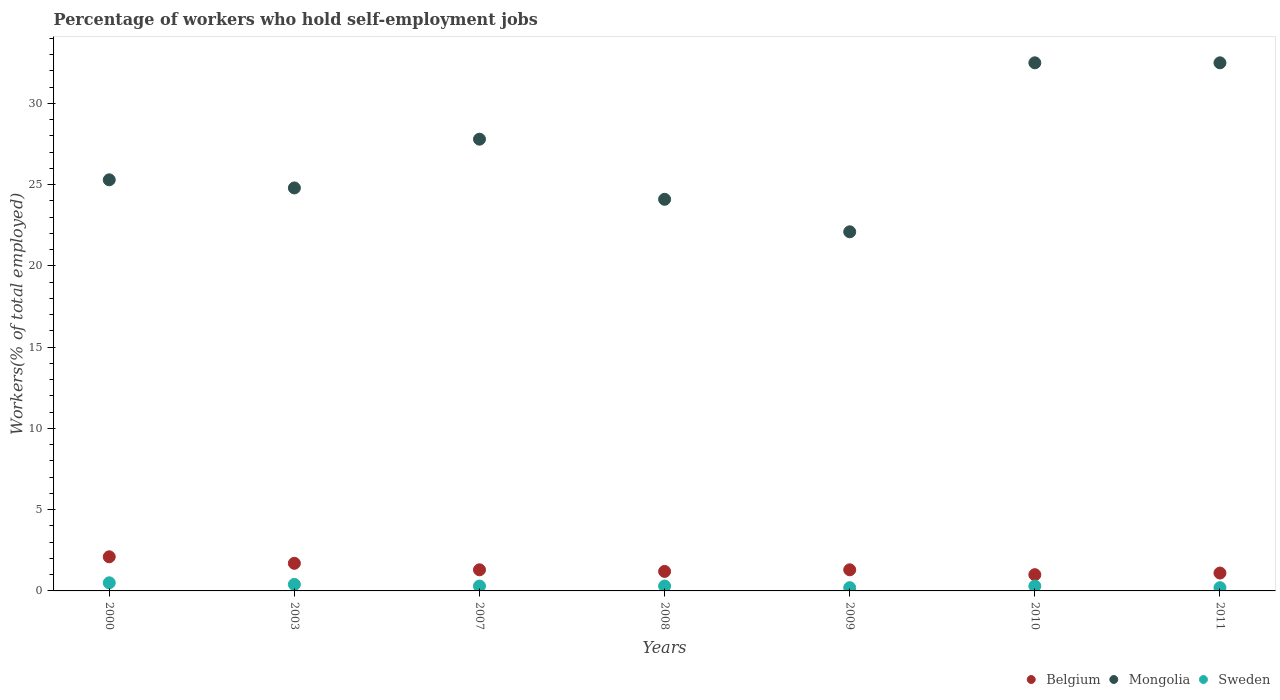How many different coloured dotlines are there?
Provide a succinct answer. 3. Is the number of dotlines equal to the number of legend labels?
Your answer should be compact. Yes. What is the percentage of self-employed workers in Belgium in 2003?
Give a very brief answer. 1.7. Across all years, what is the maximum percentage of self-employed workers in Sweden?
Ensure brevity in your answer.  0.5. Across all years, what is the minimum percentage of self-employed workers in Mongolia?
Your answer should be compact. 22.1. In which year was the percentage of self-employed workers in Belgium minimum?
Offer a terse response. 2010. What is the total percentage of self-employed workers in Sweden in the graph?
Provide a short and direct response. 2.2. What is the difference between the percentage of self-employed workers in Belgium in 2003 and that in 2007?
Your answer should be compact. 0.4. What is the difference between the percentage of self-employed workers in Sweden in 2008 and the percentage of self-employed workers in Belgium in 2010?
Your response must be concise. -0.7. What is the average percentage of self-employed workers in Sweden per year?
Offer a very short reply. 0.31. In the year 2009, what is the difference between the percentage of self-employed workers in Mongolia and percentage of self-employed workers in Sweden?
Provide a succinct answer. 21.9. In how many years, is the percentage of self-employed workers in Belgium greater than 18 %?
Keep it short and to the point. 0. What is the ratio of the percentage of self-employed workers in Belgium in 2009 to that in 2010?
Give a very brief answer. 1.3. What is the difference between the highest and the second highest percentage of self-employed workers in Mongolia?
Your answer should be compact. 0. What is the difference between the highest and the lowest percentage of self-employed workers in Mongolia?
Ensure brevity in your answer.  10.4. In how many years, is the percentage of self-employed workers in Sweden greater than the average percentage of self-employed workers in Sweden taken over all years?
Offer a terse response. 2. Is the percentage of self-employed workers in Mongolia strictly greater than the percentage of self-employed workers in Sweden over the years?
Provide a succinct answer. Yes. How many dotlines are there?
Offer a very short reply. 3. What is the difference between two consecutive major ticks on the Y-axis?
Provide a succinct answer. 5. Are the values on the major ticks of Y-axis written in scientific E-notation?
Give a very brief answer. No. Does the graph contain grids?
Make the answer very short. No. What is the title of the graph?
Offer a terse response. Percentage of workers who hold self-employment jobs. Does "Colombia" appear as one of the legend labels in the graph?
Keep it short and to the point. No. What is the label or title of the X-axis?
Your response must be concise. Years. What is the label or title of the Y-axis?
Keep it short and to the point. Workers(% of total employed). What is the Workers(% of total employed) of Belgium in 2000?
Offer a very short reply. 2.1. What is the Workers(% of total employed) in Mongolia in 2000?
Make the answer very short. 25.3. What is the Workers(% of total employed) in Belgium in 2003?
Provide a short and direct response. 1.7. What is the Workers(% of total employed) in Mongolia in 2003?
Provide a succinct answer. 24.8. What is the Workers(% of total employed) of Sweden in 2003?
Ensure brevity in your answer.  0.4. What is the Workers(% of total employed) in Belgium in 2007?
Give a very brief answer. 1.3. What is the Workers(% of total employed) of Mongolia in 2007?
Provide a short and direct response. 27.8. What is the Workers(% of total employed) in Sweden in 2007?
Your response must be concise. 0.3. What is the Workers(% of total employed) in Belgium in 2008?
Provide a short and direct response. 1.2. What is the Workers(% of total employed) of Mongolia in 2008?
Provide a short and direct response. 24.1. What is the Workers(% of total employed) in Sweden in 2008?
Keep it short and to the point. 0.3. What is the Workers(% of total employed) of Belgium in 2009?
Provide a short and direct response. 1.3. What is the Workers(% of total employed) of Mongolia in 2009?
Offer a very short reply. 22.1. What is the Workers(% of total employed) in Sweden in 2009?
Provide a short and direct response. 0.2. What is the Workers(% of total employed) of Belgium in 2010?
Your answer should be very brief. 1. What is the Workers(% of total employed) of Mongolia in 2010?
Your response must be concise. 32.5. What is the Workers(% of total employed) of Sweden in 2010?
Your answer should be very brief. 0.3. What is the Workers(% of total employed) of Belgium in 2011?
Make the answer very short. 1.1. What is the Workers(% of total employed) in Mongolia in 2011?
Your response must be concise. 32.5. What is the Workers(% of total employed) of Sweden in 2011?
Your response must be concise. 0.2. Across all years, what is the maximum Workers(% of total employed) of Belgium?
Your answer should be compact. 2.1. Across all years, what is the maximum Workers(% of total employed) of Mongolia?
Your answer should be very brief. 32.5. Across all years, what is the minimum Workers(% of total employed) of Belgium?
Ensure brevity in your answer.  1. Across all years, what is the minimum Workers(% of total employed) of Mongolia?
Your answer should be very brief. 22.1. Across all years, what is the minimum Workers(% of total employed) in Sweden?
Provide a short and direct response. 0.2. What is the total Workers(% of total employed) of Mongolia in the graph?
Provide a succinct answer. 189.1. What is the total Workers(% of total employed) of Sweden in the graph?
Provide a succinct answer. 2.2. What is the difference between the Workers(% of total employed) in Belgium in 2000 and that in 2003?
Your response must be concise. 0.4. What is the difference between the Workers(% of total employed) in Sweden in 2000 and that in 2003?
Your answer should be compact. 0.1. What is the difference between the Workers(% of total employed) of Mongolia in 2000 and that in 2007?
Your response must be concise. -2.5. What is the difference between the Workers(% of total employed) in Sweden in 2000 and that in 2007?
Keep it short and to the point. 0.2. What is the difference between the Workers(% of total employed) of Mongolia in 2000 and that in 2008?
Your answer should be compact. 1.2. What is the difference between the Workers(% of total employed) of Sweden in 2000 and that in 2008?
Make the answer very short. 0.2. What is the difference between the Workers(% of total employed) in Mongolia in 2000 and that in 2009?
Keep it short and to the point. 3.2. What is the difference between the Workers(% of total employed) of Sweden in 2000 and that in 2009?
Offer a terse response. 0.3. What is the difference between the Workers(% of total employed) of Mongolia in 2000 and that in 2010?
Provide a short and direct response. -7.2. What is the difference between the Workers(% of total employed) of Sweden in 2000 and that in 2011?
Make the answer very short. 0.3. What is the difference between the Workers(% of total employed) of Mongolia in 2003 and that in 2007?
Keep it short and to the point. -3. What is the difference between the Workers(% of total employed) of Mongolia in 2003 and that in 2008?
Ensure brevity in your answer.  0.7. What is the difference between the Workers(% of total employed) in Sweden in 2003 and that in 2008?
Give a very brief answer. 0.1. What is the difference between the Workers(% of total employed) of Belgium in 2003 and that in 2009?
Give a very brief answer. 0.4. What is the difference between the Workers(% of total employed) of Mongolia in 2003 and that in 2009?
Your answer should be compact. 2.7. What is the difference between the Workers(% of total employed) in Mongolia in 2003 and that in 2010?
Provide a succinct answer. -7.7. What is the difference between the Workers(% of total employed) in Belgium in 2003 and that in 2011?
Your answer should be compact. 0.6. What is the difference between the Workers(% of total employed) in Mongolia in 2003 and that in 2011?
Give a very brief answer. -7.7. What is the difference between the Workers(% of total employed) of Sweden in 2003 and that in 2011?
Offer a terse response. 0.2. What is the difference between the Workers(% of total employed) of Mongolia in 2007 and that in 2008?
Provide a succinct answer. 3.7. What is the difference between the Workers(% of total employed) of Belgium in 2007 and that in 2009?
Offer a terse response. 0. What is the difference between the Workers(% of total employed) of Mongolia in 2007 and that in 2009?
Offer a terse response. 5.7. What is the difference between the Workers(% of total employed) in Sweden in 2007 and that in 2010?
Provide a short and direct response. 0. What is the difference between the Workers(% of total employed) of Mongolia in 2007 and that in 2011?
Offer a terse response. -4.7. What is the difference between the Workers(% of total employed) of Belgium in 2008 and that in 2009?
Offer a terse response. -0.1. What is the difference between the Workers(% of total employed) in Sweden in 2008 and that in 2009?
Give a very brief answer. 0.1. What is the difference between the Workers(% of total employed) of Belgium in 2008 and that in 2010?
Provide a succinct answer. 0.2. What is the difference between the Workers(% of total employed) of Sweden in 2008 and that in 2010?
Your answer should be compact. 0. What is the difference between the Workers(% of total employed) in Belgium in 2008 and that in 2011?
Keep it short and to the point. 0.1. What is the difference between the Workers(% of total employed) of Sweden in 2008 and that in 2011?
Provide a short and direct response. 0.1. What is the difference between the Workers(% of total employed) in Sweden in 2009 and that in 2010?
Provide a succinct answer. -0.1. What is the difference between the Workers(% of total employed) of Belgium in 2009 and that in 2011?
Provide a short and direct response. 0.2. What is the difference between the Workers(% of total employed) in Mongolia in 2009 and that in 2011?
Give a very brief answer. -10.4. What is the difference between the Workers(% of total employed) of Sweden in 2009 and that in 2011?
Your answer should be very brief. 0. What is the difference between the Workers(% of total employed) in Belgium in 2000 and the Workers(% of total employed) in Mongolia in 2003?
Offer a terse response. -22.7. What is the difference between the Workers(% of total employed) in Belgium in 2000 and the Workers(% of total employed) in Sweden in 2003?
Ensure brevity in your answer.  1.7. What is the difference between the Workers(% of total employed) in Mongolia in 2000 and the Workers(% of total employed) in Sweden in 2003?
Provide a succinct answer. 24.9. What is the difference between the Workers(% of total employed) of Belgium in 2000 and the Workers(% of total employed) of Mongolia in 2007?
Offer a terse response. -25.7. What is the difference between the Workers(% of total employed) in Belgium in 2000 and the Workers(% of total employed) in Sweden in 2007?
Make the answer very short. 1.8. What is the difference between the Workers(% of total employed) in Belgium in 2000 and the Workers(% of total employed) in Mongolia in 2008?
Provide a succinct answer. -22. What is the difference between the Workers(% of total employed) of Mongolia in 2000 and the Workers(% of total employed) of Sweden in 2008?
Ensure brevity in your answer.  25. What is the difference between the Workers(% of total employed) of Belgium in 2000 and the Workers(% of total employed) of Mongolia in 2009?
Offer a very short reply. -20. What is the difference between the Workers(% of total employed) in Belgium in 2000 and the Workers(% of total employed) in Sweden in 2009?
Provide a short and direct response. 1.9. What is the difference between the Workers(% of total employed) in Mongolia in 2000 and the Workers(% of total employed) in Sweden in 2009?
Make the answer very short. 25.1. What is the difference between the Workers(% of total employed) in Belgium in 2000 and the Workers(% of total employed) in Mongolia in 2010?
Your response must be concise. -30.4. What is the difference between the Workers(% of total employed) of Mongolia in 2000 and the Workers(% of total employed) of Sweden in 2010?
Offer a very short reply. 25. What is the difference between the Workers(% of total employed) of Belgium in 2000 and the Workers(% of total employed) of Mongolia in 2011?
Your response must be concise. -30.4. What is the difference between the Workers(% of total employed) in Belgium in 2000 and the Workers(% of total employed) in Sweden in 2011?
Keep it short and to the point. 1.9. What is the difference between the Workers(% of total employed) in Mongolia in 2000 and the Workers(% of total employed) in Sweden in 2011?
Make the answer very short. 25.1. What is the difference between the Workers(% of total employed) of Belgium in 2003 and the Workers(% of total employed) of Mongolia in 2007?
Offer a very short reply. -26.1. What is the difference between the Workers(% of total employed) in Mongolia in 2003 and the Workers(% of total employed) in Sweden in 2007?
Your answer should be very brief. 24.5. What is the difference between the Workers(% of total employed) in Belgium in 2003 and the Workers(% of total employed) in Mongolia in 2008?
Make the answer very short. -22.4. What is the difference between the Workers(% of total employed) in Belgium in 2003 and the Workers(% of total employed) in Sweden in 2008?
Keep it short and to the point. 1.4. What is the difference between the Workers(% of total employed) in Belgium in 2003 and the Workers(% of total employed) in Mongolia in 2009?
Keep it short and to the point. -20.4. What is the difference between the Workers(% of total employed) in Belgium in 2003 and the Workers(% of total employed) in Sweden in 2009?
Your answer should be very brief. 1.5. What is the difference between the Workers(% of total employed) of Mongolia in 2003 and the Workers(% of total employed) of Sweden in 2009?
Make the answer very short. 24.6. What is the difference between the Workers(% of total employed) in Belgium in 2003 and the Workers(% of total employed) in Mongolia in 2010?
Provide a short and direct response. -30.8. What is the difference between the Workers(% of total employed) in Belgium in 2003 and the Workers(% of total employed) in Sweden in 2010?
Keep it short and to the point. 1.4. What is the difference between the Workers(% of total employed) in Belgium in 2003 and the Workers(% of total employed) in Mongolia in 2011?
Keep it short and to the point. -30.8. What is the difference between the Workers(% of total employed) in Mongolia in 2003 and the Workers(% of total employed) in Sweden in 2011?
Ensure brevity in your answer.  24.6. What is the difference between the Workers(% of total employed) in Belgium in 2007 and the Workers(% of total employed) in Mongolia in 2008?
Your response must be concise. -22.8. What is the difference between the Workers(% of total employed) in Belgium in 2007 and the Workers(% of total employed) in Sweden in 2008?
Offer a very short reply. 1. What is the difference between the Workers(% of total employed) in Belgium in 2007 and the Workers(% of total employed) in Mongolia in 2009?
Ensure brevity in your answer.  -20.8. What is the difference between the Workers(% of total employed) in Mongolia in 2007 and the Workers(% of total employed) in Sweden in 2009?
Your answer should be very brief. 27.6. What is the difference between the Workers(% of total employed) in Belgium in 2007 and the Workers(% of total employed) in Mongolia in 2010?
Ensure brevity in your answer.  -31.2. What is the difference between the Workers(% of total employed) of Belgium in 2007 and the Workers(% of total employed) of Sweden in 2010?
Provide a succinct answer. 1. What is the difference between the Workers(% of total employed) in Belgium in 2007 and the Workers(% of total employed) in Mongolia in 2011?
Provide a succinct answer. -31.2. What is the difference between the Workers(% of total employed) of Mongolia in 2007 and the Workers(% of total employed) of Sweden in 2011?
Offer a very short reply. 27.6. What is the difference between the Workers(% of total employed) in Belgium in 2008 and the Workers(% of total employed) in Mongolia in 2009?
Provide a short and direct response. -20.9. What is the difference between the Workers(% of total employed) of Belgium in 2008 and the Workers(% of total employed) of Sweden in 2009?
Your answer should be compact. 1. What is the difference between the Workers(% of total employed) of Mongolia in 2008 and the Workers(% of total employed) of Sweden in 2009?
Offer a very short reply. 23.9. What is the difference between the Workers(% of total employed) of Belgium in 2008 and the Workers(% of total employed) of Mongolia in 2010?
Your response must be concise. -31.3. What is the difference between the Workers(% of total employed) of Mongolia in 2008 and the Workers(% of total employed) of Sweden in 2010?
Give a very brief answer. 23.8. What is the difference between the Workers(% of total employed) in Belgium in 2008 and the Workers(% of total employed) in Mongolia in 2011?
Keep it short and to the point. -31.3. What is the difference between the Workers(% of total employed) in Mongolia in 2008 and the Workers(% of total employed) in Sweden in 2011?
Provide a short and direct response. 23.9. What is the difference between the Workers(% of total employed) in Belgium in 2009 and the Workers(% of total employed) in Mongolia in 2010?
Your answer should be compact. -31.2. What is the difference between the Workers(% of total employed) in Belgium in 2009 and the Workers(% of total employed) in Sweden in 2010?
Ensure brevity in your answer.  1. What is the difference between the Workers(% of total employed) of Mongolia in 2009 and the Workers(% of total employed) of Sweden in 2010?
Offer a very short reply. 21.8. What is the difference between the Workers(% of total employed) of Belgium in 2009 and the Workers(% of total employed) of Mongolia in 2011?
Your answer should be very brief. -31.2. What is the difference between the Workers(% of total employed) in Belgium in 2009 and the Workers(% of total employed) in Sweden in 2011?
Your answer should be compact. 1.1. What is the difference between the Workers(% of total employed) of Mongolia in 2009 and the Workers(% of total employed) of Sweden in 2011?
Make the answer very short. 21.9. What is the difference between the Workers(% of total employed) in Belgium in 2010 and the Workers(% of total employed) in Mongolia in 2011?
Offer a terse response. -31.5. What is the difference between the Workers(% of total employed) in Mongolia in 2010 and the Workers(% of total employed) in Sweden in 2011?
Make the answer very short. 32.3. What is the average Workers(% of total employed) in Belgium per year?
Keep it short and to the point. 1.39. What is the average Workers(% of total employed) of Mongolia per year?
Your answer should be very brief. 27.01. What is the average Workers(% of total employed) of Sweden per year?
Ensure brevity in your answer.  0.31. In the year 2000, what is the difference between the Workers(% of total employed) in Belgium and Workers(% of total employed) in Mongolia?
Your response must be concise. -23.2. In the year 2000, what is the difference between the Workers(% of total employed) of Belgium and Workers(% of total employed) of Sweden?
Give a very brief answer. 1.6. In the year 2000, what is the difference between the Workers(% of total employed) in Mongolia and Workers(% of total employed) in Sweden?
Ensure brevity in your answer.  24.8. In the year 2003, what is the difference between the Workers(% of total employed) in Belgium and Workers(% of total employed) in Mongolia?
Offer a terse response. -23.1. In the year 2003, what is the difference between the Workers(% of total employed) in Belgium and Workers(% of total employed) in Sweden?
Give a very brief answer. 1.3. In the year 2003, what is the difference between the Workers(% of total employed) of Mongolia and Workers(% of total employed) of Sweden?
Your response must be concise. 24.4. In the year 2007, what is the difference between the Workers(% of total employed) in Belgium and Workers(% of total employed) in Mongolia?
Give a very brief answer. -26.5. In the year 2007, what is the difference between the Workers(% of total employed) of Mongolia and Workers(% of total employed) of Sweden?
Your response must be concise. 27.5. In the year 2008, what is the difference between the Workers(% of total employed) in Belgium and Workers(% of total employed) in Mongolia?
Offer a very short reply. -22.9. In the year 2008, what is the difference between the Workers(% of total employed) of Mongolia and Workers(% of total employed) of Sweden?
Offer a very short reply. 23.8. In the year 2009, what is the difference between the Workers(% of total employed) of Belgium and Workers(% of total employed) of Mongolia?
Give a very brief answer. -20.8. In the year 2009, what is the difference between the Workers(% of total employed) in Belgium and Workers(% of total employed) in Sweden?
Your answer should be very brief. 1.1. In the year 2009, what is the difference between the Workers(% of total employed) in Mongolia and Workers(% of total employed) in Sweden?
Provide a succinct answer. 21.9. In the year 2010, what is the difference between the Workers(% of total employed) in Belgium and Workers(% of total employed) in Mongolia?
Your answer should be very brief. -31.5. In the year 2010, what is the difference between the Workers(% of total employed) in Mongolia and Workers(% of total employed) in Sweden?
Provide a short and direct response. 32.2. In the year 2011, what is the difference between the Workers(% of total employed) in Belgium and Workers(% of total employed) in Mongolia?
Provide a succinct answer. -31.4. In the year 2011, what is the difference between the Workers(% of total employed) of Belgium and Workers(% of total employed) of Sweden?
Provide a succinct answer. 0.9. In the year 2011, what is the difference between the Workers(% of total employed) of Mongolia and Workers(% of total employed) of Sweden?
Keep it short and to the point. 32.3. What is the ratio of the Workers(% of total employed) of Belgium in 2000 to that in 2003?
Your answer should be very brief. 1.24. What is the ratio of the Workers(% of total employed) in Mongolia in 2000 to that in 2003?
Provide a short and direct response. 1.02. What is the ratio of the Workers(% of total employed) of Sweden in 2000 to that in 2003?
Offer a very short reply. 1.25. What is the ratio of the Workers(% of total employed) of Belgium in 2000 to that in 2007?
Provide a succinct answer. 1.62. What is the ratio of the Workers(% of total employed) of Mongolia in 2000 to that in 2007?
Provide a succinct answer. 0.91. What is the ratio of the Workers(% of total employed) of Sweden in 2000 to that in 2007?
Provide a short and direct response. 1.67. What is the ratio of the Workers(% of total employed) in Belgium in 2000 to that in 2008?
Provide a succinct answer. 1.75. What is the ratio of the Workers(% of total employed) in Mongolia in 2000 to that in 2008?
Your answer should be very brief. 1.05. What is the ratio of the Workers(% of total employed) of Sweden in 2000 to that in 2008?
Keep it short and to the point. 1.67. What is the ratio of the Workers(% of total employed) of Belgium in 2000 to that in 2009?
Offer a terse response. 1.62. What is the ratio of the Workers(% of total employed) of Mongolia in 2000 to that in 2009?
Make the answer very short. 1.14. What is the ratio of the Workers(% of total employed) in Belgium in 2000 to that in 2010?
Provide a short and direct response. 2.1. What is the ratio of the Workers(% of total employed) in Mongolia in 2000 to that in 2010?
Provide a short and direct response. 0.78. What is the ratio of the Workers(% of total employed) in Sweden in 2000 to that in 2010?
Provide a succinct answer. 1.67. What is the ratio of the Workers(% of total employed) of Belgium in 2000 to that in 2011?
Your answer should be compact. 1.91. What is the ratio of the Workers(% of total employed) of Mongolia in 2000 to that in 2011?
Offer a terse response. 0.78. What is the ratio of the Workers(% of total employed) of Belgium in 2003 to that in 2007?
Keep it short and to the point. 1.31. What is the ratio of the Workers(% of total employed) of Mongolia in 2003 to that in 2007?
Ensure brevity in your answer.  0.89. What is the ratio of the Workers(% of total employed) in Belgium in 2003 to that in 2008?
Your answer should be compact. 1.42. What is the ratio of the Workers(% of total employed) in Mongolia in 2003 to that in 2008?
Offer a terse response. 1.03. What is the ratio of the Workers(% of total employed) in Sweden in 2003 to that in 2008?
Give a very brief answer. 1.33. What is the ratio of the Workers(% of total employed) in Belgium in 2003 to that in 2009?
Your response must be concise. 1.31. What is the ratio of the Workers(% of total employed) in Mongolia in 2003 to that in 2009?
Give a very brief answer. 1.12. What is the ratio of the Workers(% of total employed) in Mongolia in 2003 to that in 2010?
Keep it short and to the point. 0.76. What is the ratio of the Workers(% of total employed) of Belgium in 2003 to that in 2011?
Ensure brevity in your answer.  1.55. What is the ratio of the Workers(% of total employed) in Mongolia in 2003 to that in 2011?
Your answer should be compact. 0.76. What is the ratio of the Workers(% of total employed) of Mongolia in 2007 to that in 2008?
Keep it short and to the point. 1.15. What is the ratio of the Workers(% of total employed) of Sweden in 2007 to that in 2008?
Offer a very short reply. 1. What is the ratio of the Workers(% of total employed) in Mongolia in 2007 to that in 2009?
Give a very brief answer. 1.26. What is the ratio of the Workers(% of total employed) in Mongolia in 2007 to that in 2010?
Provide a succinct answer. 0.86. What is the ratio of the Workers(% of total employed) of Sweden in 2007 to that in 2010?
Offer a terse response. 1. What is the ratio of the Workers(% of total employed) of Belgium in 2007 to that in 2011?
Give a very brief answer. 1.18. What is the ratio of the Workers(% of total employed) of Mongolia in 2007 to that in 2011?
Ensure brevity in your answer.  0.86. What is the ratio of the Workers(% of total employed) of Sweden in 2007 to that in 2011?
Make the answer very short. 1.5. What is the ratio of the Workers(% of total employed) in Mongolia in 2008 to that in 2009?
Your answer should be compact. 1.09. What is the ratio of the Workers(% of total employed) of Mongolia in 2008 to that in 2010?
Your response must be concise. 0.74. What is the ratio of the Workers(% of total employed) in Sweden in 2008 to that in 2010?
Give a very brief answer. 1. What is the ratio of the Workers(% of total employed) of Mongolia in 2008 to that in 2011?
Offer a terse response. 0.74. What is the ratio of the Workers(% of total employed) in Mongolia in 2009 to that in 2010?
Provide a succinct answer. 0.68. What is the ratio of the Workers(% of total employed) of Belgium in 2009 to that in 2011?
Give a very brief answer. 1.18. What is the ratio of the Workers(% of total employed) in Mongolia in 2009 to that in 2011?
Provide a succinct answer. 0.68. What is the ratio of the Workers(% of total employed) in Sweden in 2009 to that in 2011?
Your answer should be compact. 1. What is the ratio of the Workers(% of total employed) of Belgium in 2010 to that in 2011?
Make the answer very short. 0.91. What is the difference between the highest and the second highest Workers(% of total employed) in Belgium?
Provide a succinct answer. 0.4. What is the difference between the highest and the second highest Workers(% of total employed) of Mongolia?
Your answer should be compact. 0. 